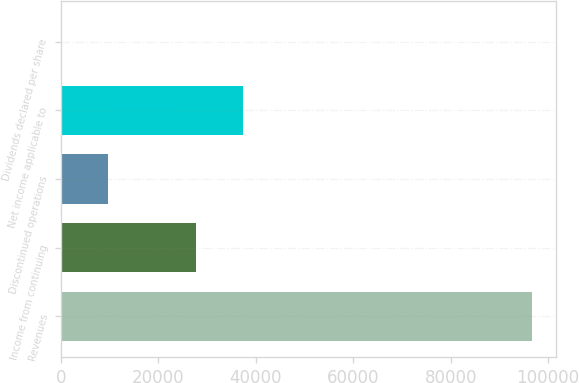Convert chart to OTSL. <chart><loc_0><loc_0><loc_500><loc_500><bar_chart><fcel>Revenues<fcel>Income from continuing<fcel>Discontinued operations<fcel>Net income applicable to<fcel>Dividends declared per share<nl><fcel>96736<fcel>27607<fcel>9673.96<fcel>37280.6<fcel>0.4<nl></chart> 